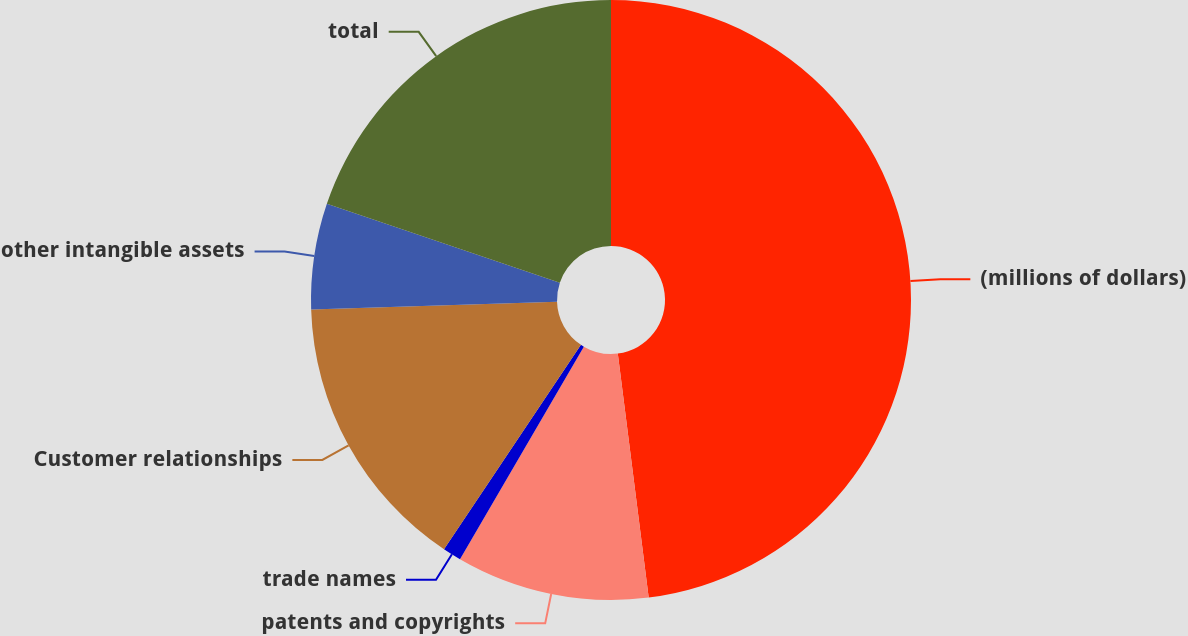<chart> <loc_0><loc_0><loc_500><loc_500><pie_chart><fcel>(millions of dollars)<fcel>patents and copyrights<fcel>trade names<fcel>Customer relationships<fcel>other intangible assets<fcel>total<nl><fcel>47.99%<fcel>10.4%<fcel>1.0%<fcel>15.1%<fcel>5.7%<fcel>19.8%<nl></chart> 